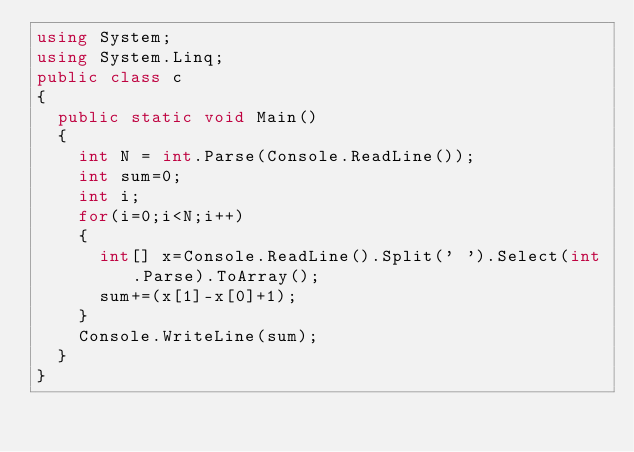Convert code to text. <code><loc_0><loc_0><loc_500><loc_500><_C#_>using System;
using System.Linq;
public class c
{
  public static void Main()
  {
    int N = int.Parse(Console.ReadLine());
    int sum=0;
    int i;
    for(i=0;i<N;i++)
    {
      int[] x=Console.ReadLine().Split(' ').Select(int.Parse).ToArray();
      sum+=(x[1]-x[0]+1);
    }
    Console.WriteLine(sum);
  }
}</code> 